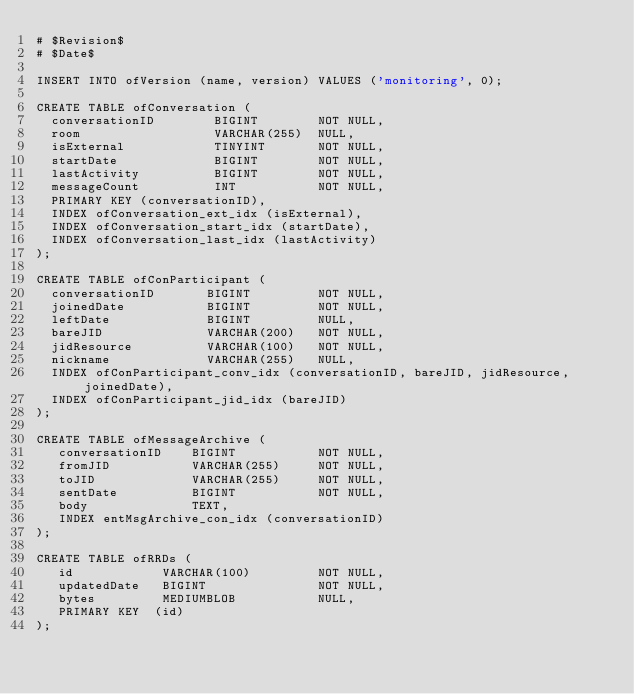Convert code to text. <code><loc_0><loc_0><loc_500><loc_500><_SQL_># $Revision$
# $Date$

INSERT INTO ofVersion (name, version) VALUES ('monitoring', 0);

CREATE TABLE ofConversation (
  conversationID        BIGINT        NOT NULL,
  room                  VARCHAR(255)  NULL,
  isExternal            TINYINT       NOT NULL,
  startDate             BIGINT        NOT NULL,
  lastActivity          BIGINT        NOT NULL,
  messageCount          INT           NOT NULL,
  PRIMARY KEY (conversationID),
  INDEX ofConversation_ext_idx (isExternal),
  INDEX ofConversation_start_idx (startDate),
  INDEX ofConversation_last_idx (lastActivity)
);

CREATE TABLE ofConParticipant (
  conversationID       BIGINT         NOT NULL,
  joinedDate           BIGINT         NOT NULL,
  leftDate             BIGINT         NULL,
  bareJID              VARCHAR(200)   NOT NULL,
  jidResource          VARCHAR(100)   NOT NULL,
  nickname             VARCHAR(255)   NULL,
  INDEX ofConParticipant_conv_idx (conversationID, bareJID, jidResource, joinedDate),
  INDEX ofConParticipant_jid_idx (bareJID)
);

CREATE TABLE ofMessageArchive (
   conversationID    BIGINT           NOT NULL,
   fromJID           VARCHAR(255)     NOT NULL,
   toJID             VARCHAR(255)     NOT NULL,
   sentDate          BIGINT           NOT NULL,
   body              TEXT,
   INDEX entMsgArchive_con_idx (conversationID)
);

CREATE TABLE ofRRDs (
   id            VARCHAR(100)         NOT NULL,
   updatedDate   BIGINT               NOT NULL,
   bytes         MEDIUMBLOB           NULL,
   PRIMARY KEY  (id)
);

</code> 